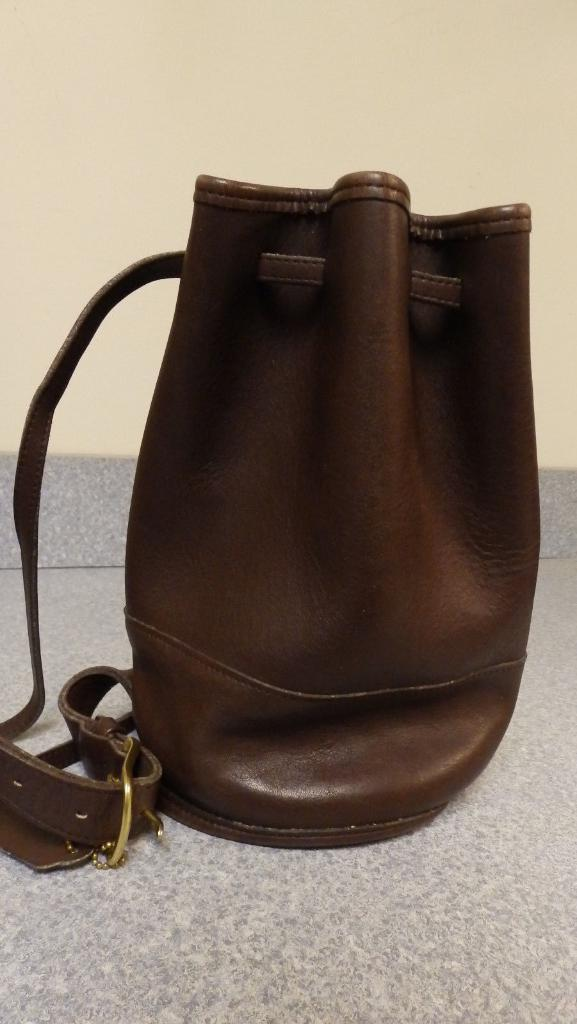What object is on the floor in the image? There is a bag on the floor in the image. What feature does the bag have? The bag has a belt attached to it. What can be seen in the background of the image? There is a wall in the background of the image. What type of prose does the writer in the image specialize in? There is no writer present in the image, so it is not possible to determine the type of prose they specialize in. 